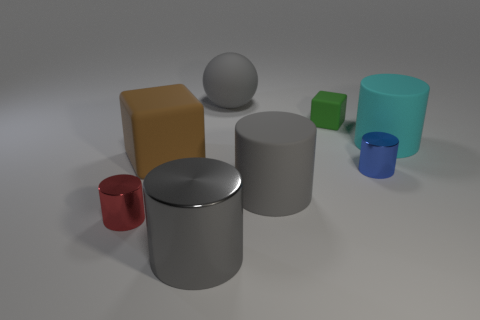Subtract all large gray rubber cylinders. How many cylinders are left? 4 Subtract all blue cylinders. How many cylinders are left? 4 Subtract all green cylinders. Subtract all red blocks. How many cylinders are left? 5 Add 1 yellow balls. How many objects exist? 9 Subtract all cylinders. How many objects are left? 3 Add 2 large cyan matte things. How many large cyan matte things are left? 3 Add 1 purple matte cylinders. How many purple matte cylinders exist? 1 Subtract 1 red cylinders. How many objects are left? 7 Subtract all small gray matte cylinders. Subtract all big metallic things. How many objects are left? 7 